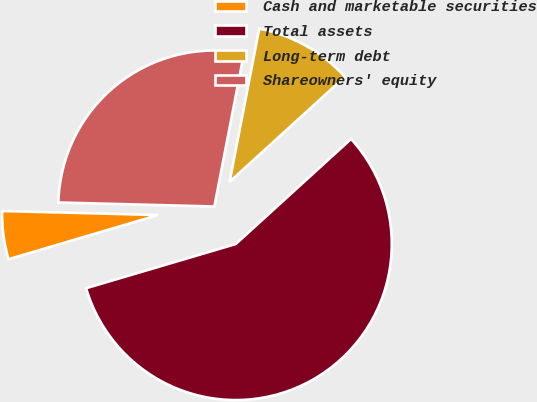<chart> <loc_0><loc_0><loc_500><loc_500><pie_chart><fcel>Cash and marketable securities<fcel>Total assets<fcel>Long-term debt<fcel>Shareowners' equity<nl><fcel>4.98%<fcel>57.19%<fcel>10.2%<fcel>27.63%<nl></chart> 